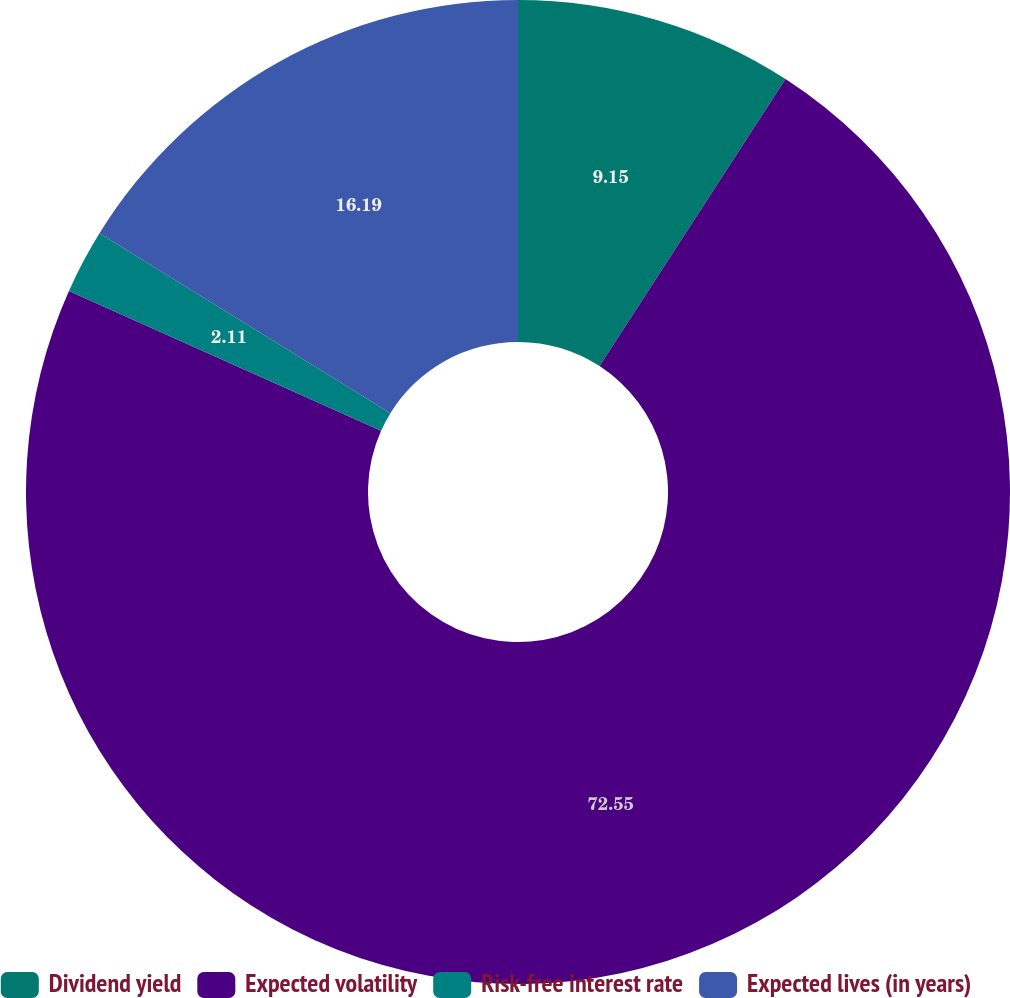<chart> <loc_0><loc_0><loc_500><loc_500><pie_chart><fcel>Dividend yield<fcel>Expected volatility<fcel>Risk-free interest rate<fcel>Expected lives (in years)<nl><fcel>9.15%<fcel>72.55%<fcel>2.11%<fcel>16.19%<nl></chart> 